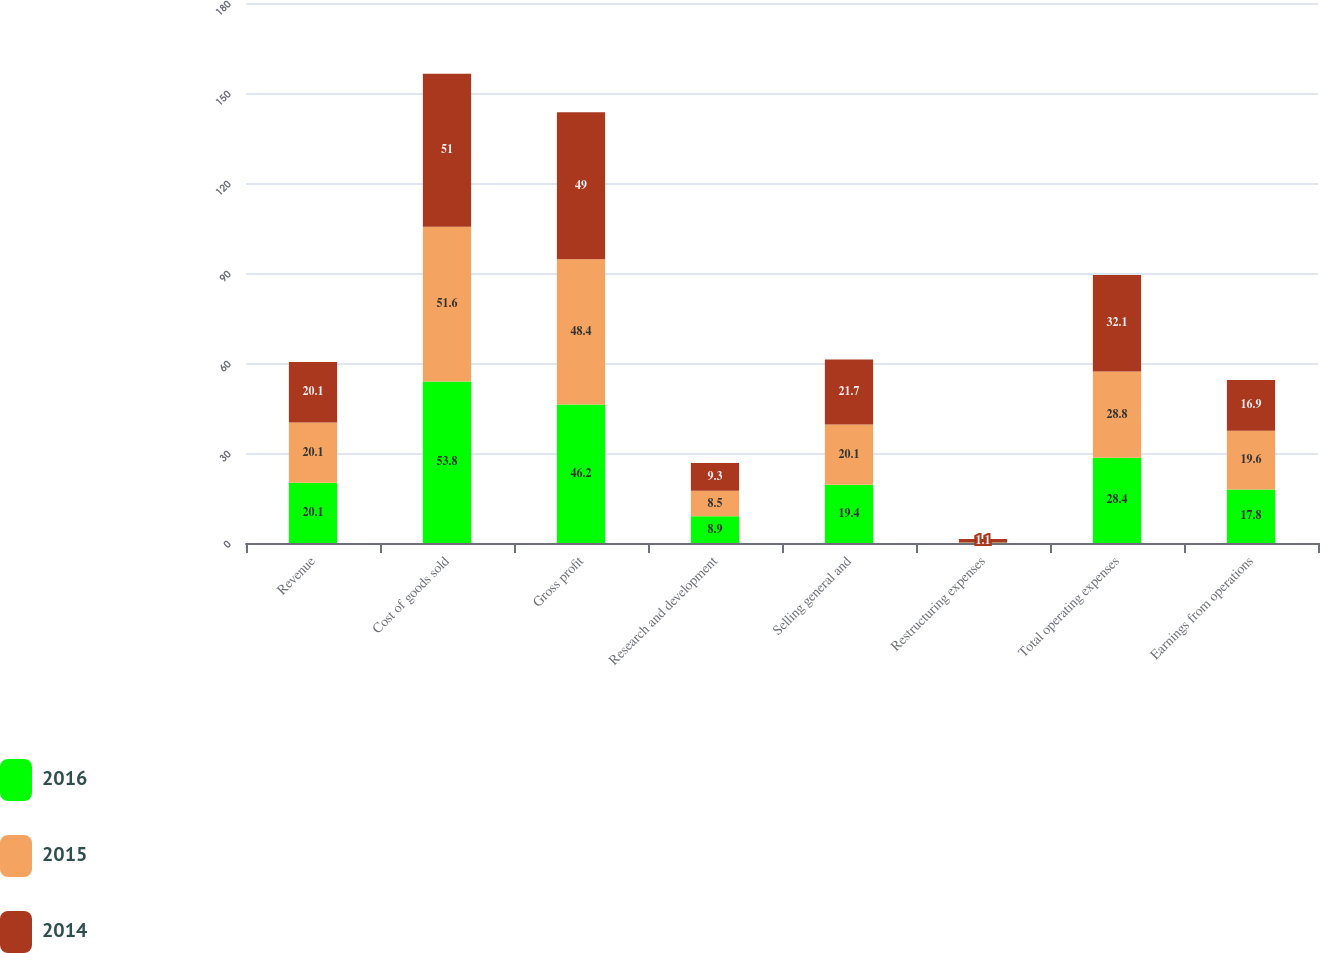Convert chart. <chart><loc_0><loc_0><loc_500><loc_500><stacked_bar_chart><ecel><fcel>Revenue<fcel>Cost of goods sold<fcel>Gross profit<fcel>Research and development<fcel>Selling general and<fcel>Restructuring expenses<fcel>Total operating expenses<fcel>Earnings from operations<nl><fcel>2016<fcel>20.1<fcel>53.8<fcel>46.2<fcel>8.9<fcel>19.4<fcel>0.1<fcel>28.4<fcel>17.8<nl><fcel>2015<fcel>20.1<fcel>51.6<fcel>48.4<fcel>8.5<fcel>20.1<fcel>0.1<fcel>28.8<fcel>19.6<nl><fcel>2014<fcel>20.1<fcel>51<fcel>49<fcel>9.3<fcel>21.7<fcel>1.1<fcel>32.1<fcel>16.9<nl></chart> 